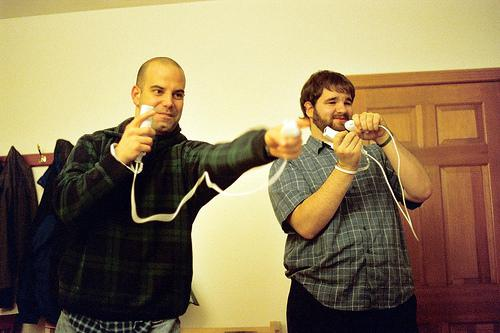Question: what are the men holding?
Choices:
A. Remotes.
B. Cell phone.
C. Babies.
D. Controllers.
Answer with the letter. Answer: D Question: why is it so bright?
Choices:
A. Daytime.
B. Sun is out.
C. Outdoors.
D. Lights are on.
Answer with the letter. Answer: D 